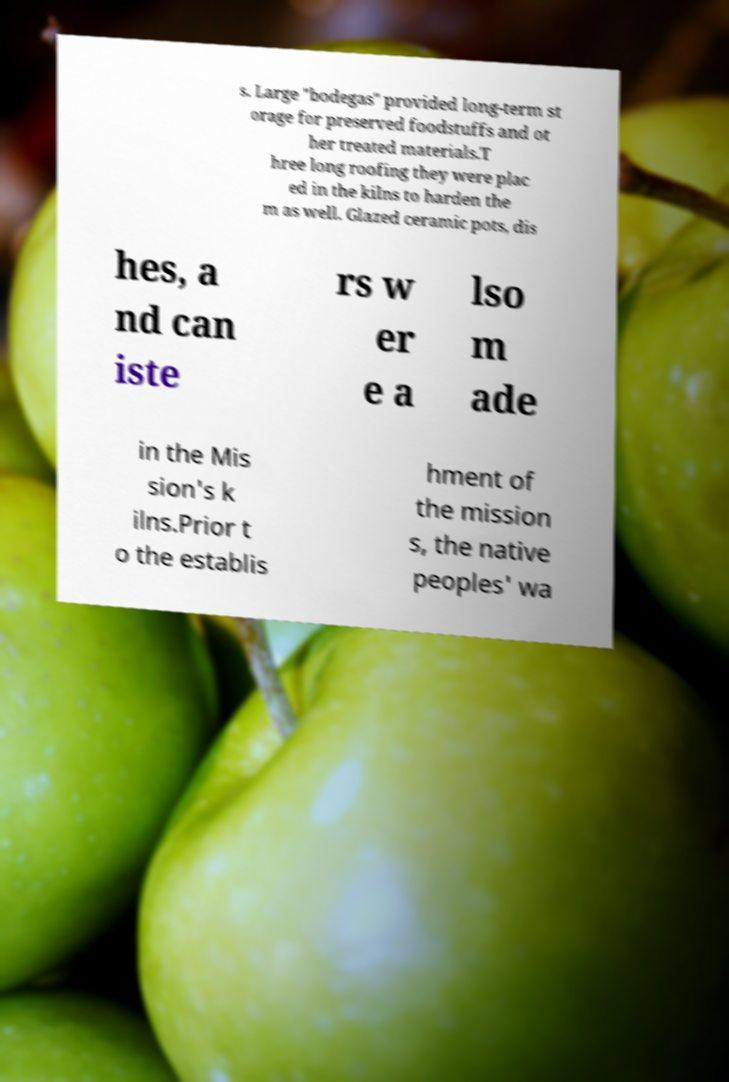For documentation purposes, I need the text within this image transcribed. Could you provide that? s. Large "bodegas" provided long-term st orage for preserved foodstuffs and ot her treated materials.T hree long roofing they were plac ed in the kilns to harden the m as well. Glazed ceramic pots, dis hes, a nd can iste rs w er e a lso m ade in the Mis sion's k ilns.Prior t o the establis hment of the mission s, the native peoples' wa 